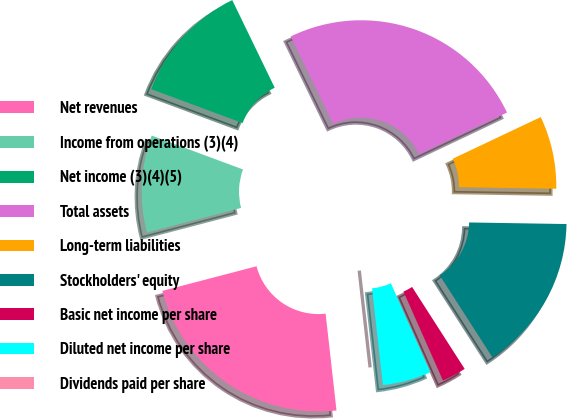Convert chart to OTSL. <chart><loc_0><loc_0><loc_500><loc_500><pie_chart><fcel>Net revenues<fcel>Income from operations (3)(4)<fcel>Net income (3)(4)(5)<fcel>Total assets<fcel>Long-term liabilities<fcel>Stockholders' equity<fcel>Basic net income per share<fcel>Diluted net income per share<fcel>Dividends paid per share<nl><fcel>22.71%<fcel>9.73%<fcel>12.16%<fcel>25.14%<fcel>7.3%<fcel>15.66%<fcel>2.43%<fcel>4.87%<fcel>0.0%<nl></chart> 